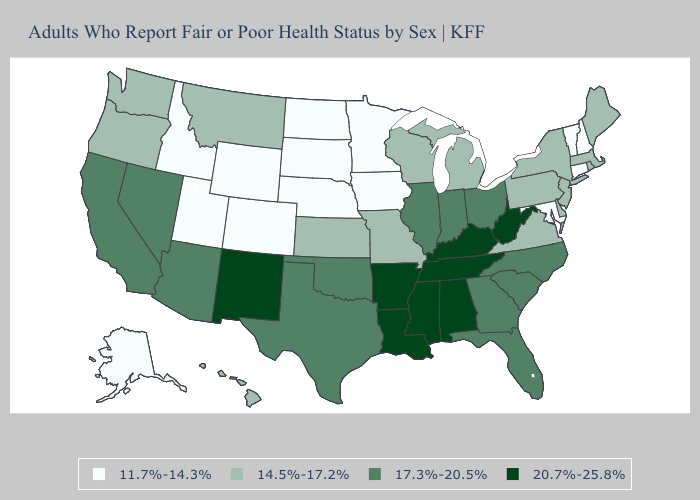How many symbols are there in the legend?
Write a very short answer. 4. Does Massachusetts have the lowest value in the USA?
Short answer required. No. Does the first symbol in the legend represent the smallest category?
Short answer required. Yes. Which states hav the highest value in the Northeast?
Answer briefly. Maine, Massachusetts, New Jersey, New York, Pennsylvania, Rhode Island. Does Maine have the same value as Indiana?
Be succinct. No. Name the states that have a value in the range 17.3%-20.5%?
Write a very short answer. Arizona, California, Florida, Georgia, Illinois, Indiana, Nevada, North Carolina, Ohio, Oklahoma, South Carolina, Texas. What is the value of New York?
Short answer required. 14.5%-17.2%. What is the highest value in the USA?
Write a very short answer. 20.7%-25.8%. Among the states that border Indiana , which have the lowest value?
Answer briefly. Michigan. Which states have the highest value in the USA?
Give a very brief answer. Alabama, Arkansas, Kentucky, Louisiana, Mississippi, New Mexico, Tennessee, West Virginia. What is the lowest value in states that border Connecticut?
Quick response, please. 14.5%-17.2%. Name the states that have a value in the range 11.7%-14.3%?
Write a very short answer. Alaska, Colorado, Connecticut, Idaho, Iowa, Maryland, Minnesota, Nebraska, New Hampshire, North Dakota, South Dakota, Utah, Vermont, Wyoming. What is the lowest value in the USA?
Give a very brief answer. 11.7%-14.3%. Does Rhode Island have the lowest value in the Northeast?
Keep it brief. No. 